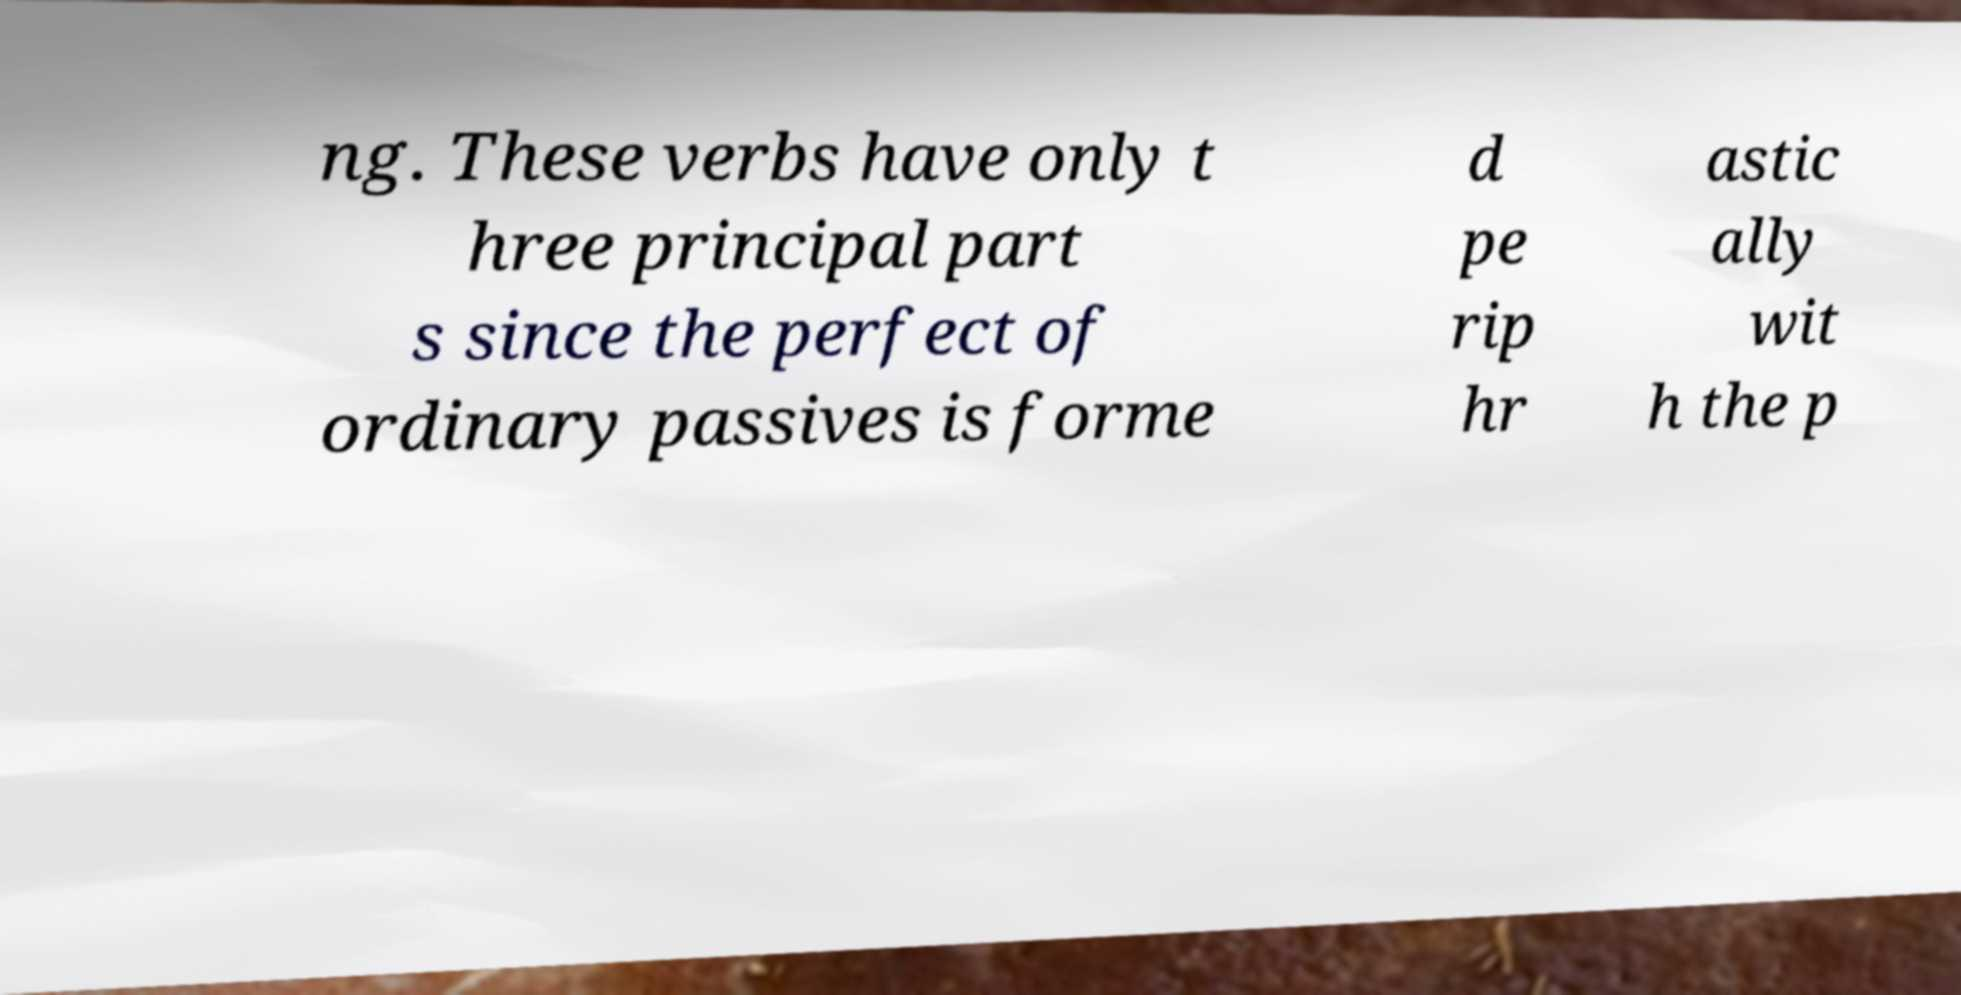For documentation purposes, I need the text within this image transcribed. Could you provide that? ng. These verbs have only t hree principal part s since the perfect of ordinary passives is forme d pe rip hr astic ally wit h the p 